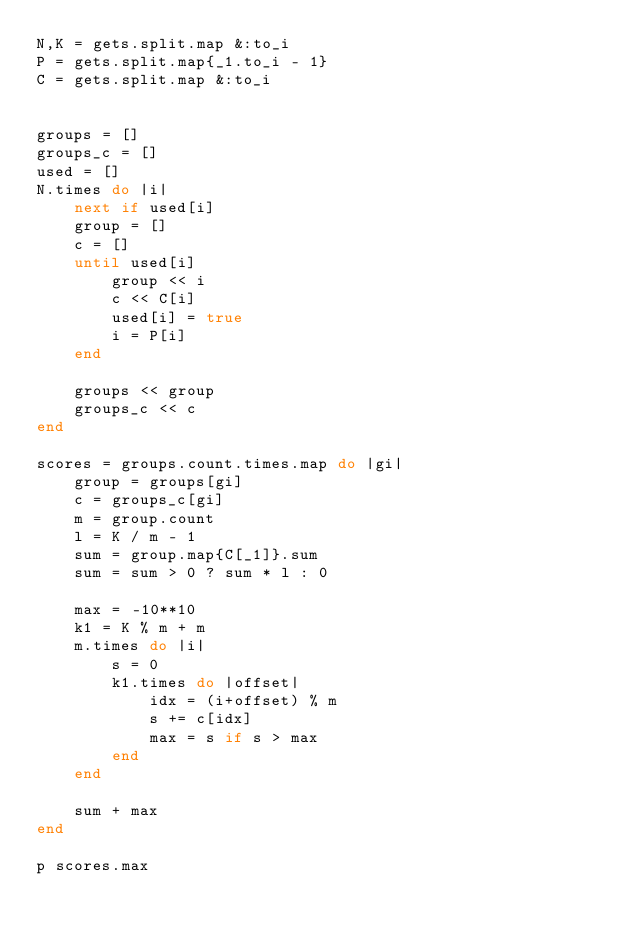Convert code to text. <code><loc_0><loc_0><loc_500><loc_500><_Ruby_>N,K = gets.split.map &:to_i
P = gets.split.map{_1.to_i - 1}
C = gets.split.map &:to_i


groups = []
groups_c = []
used = []
N.times do |i|
    next if used[i]
    group = []
    c = []
    until used[i]
        group << i
        c << C[i]
        used[i] = true
        i = P[i]
    end

    groups << group
    groups_c << c
end

scores = groups.count.times.map do |gi|
    group = groups[gi]
    c = groups_c[gi]
    m = group.count
    l = K / m - 1
    sum = group.map{C[_1]}.sum
    sum = sum > 0 ? sum * l : 0

    max = -10**10 
    k1 = K % m + m
    m.times do |i|
        s = 0
        k1.times do |offset|
            idx = (i+offset) % m
            s += c[idx]
            max = s if s > max
        end
    end

    sum + max
end

p scores.max</code> 